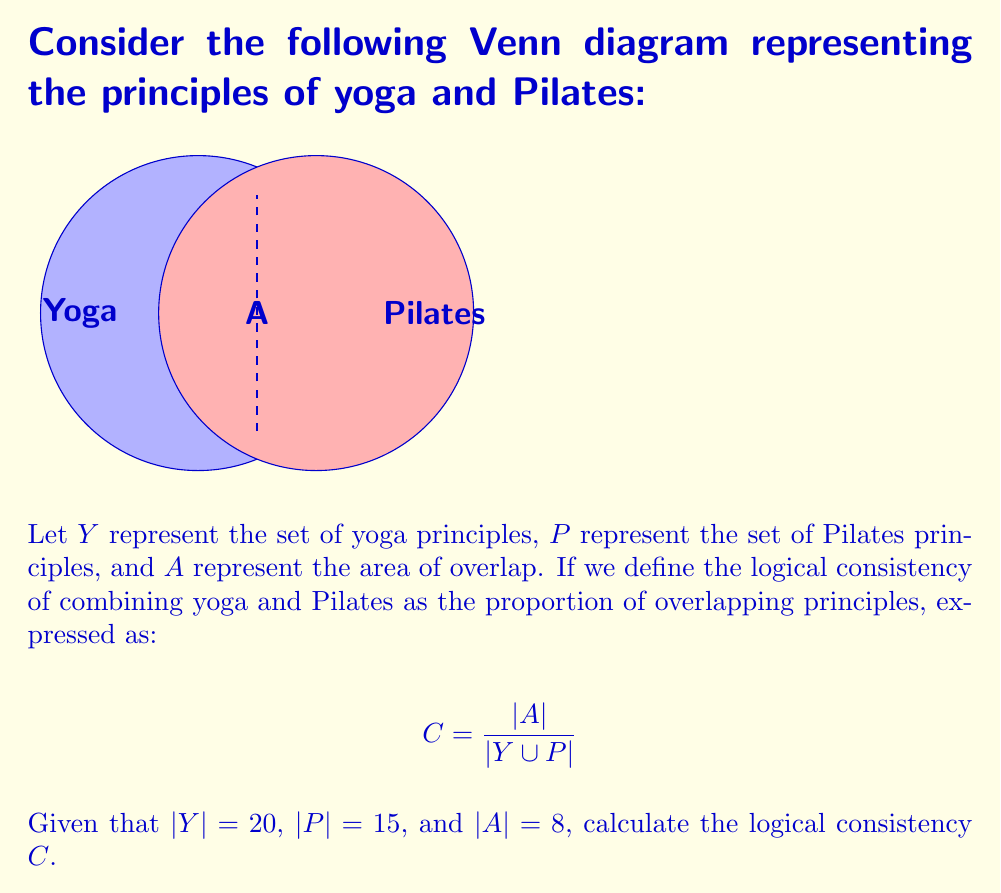Can you answer this question? To solve this problem, we'll follow these steps:

1) First, we need to calculate $|Y \cup P|$, which is the total number of unique principles in both yoga and Pilates.

2) We can use the inclusion-exclusion principle:
   $|Y \cup P| = |Y| + |P| - |A|$

3) Substituting the given values:
   $|Y \cup P| = 20 + 15 - 8 = 27$

4) Now we can calculate the logical consistency $C$:
   $$ C = \frac{|A|}{|Y \cup P|} = \frac{8}{27} $$

5) This fraction can be reduced to its simplest form:
   $$ C = \frac{8}{27} $$

Thus, the logical consistency of combining yoga philosophy with Pilates principles is $\frac{8}{27}$ or approximately 0.2963 or 29.63%.
Answer: $\frac{8}{27}$ 